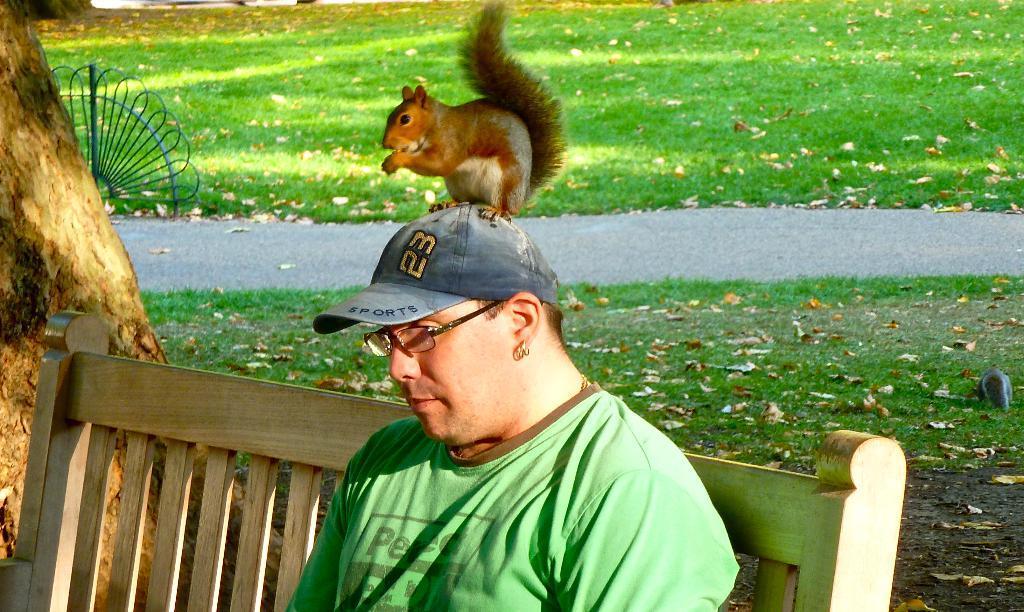Can you describe this image briefly? In this picture there is man sitting on the bench, wearing a hat and spectacles. On his head there is a squirrel sitting. In the left side there is a tree. In the background, there is a garden and a road here. 